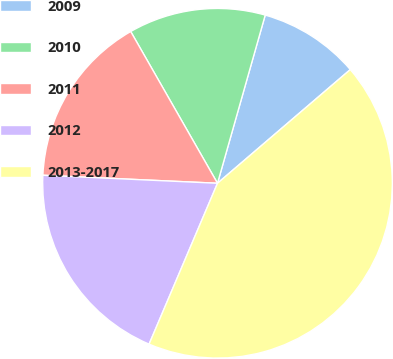<chart> <loc_0><loc_0><loc_500><loc_500><pie_chart><fcel>2009<fcel>2010<fcel>2011<fcel>2012<fcel>2013-2017<nl><fcel>9.33%<fcel>12.67%<fcel>16.0%<fcel>19.33%<fcel>42.67%<nl></chart> 